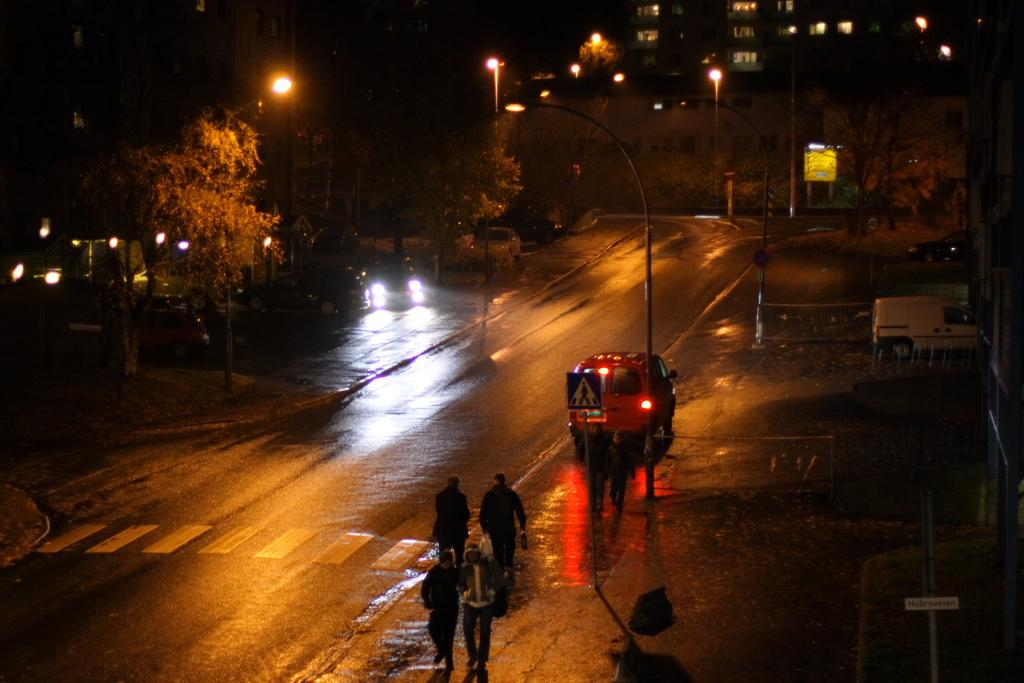What is the main feature of the image? There is a road in the image. What else can be seen in the image besides the road? There are people standing, vehicles, poles, lights, trees, and buildings in the background. Can you describe the lighting conditions in the image? The sky is dark in the background of the image. How many ducks are flying over the buildings in the image? There are no ducks present in the image. What is the thumb doing in the image? There is no thumb visible in the image. 